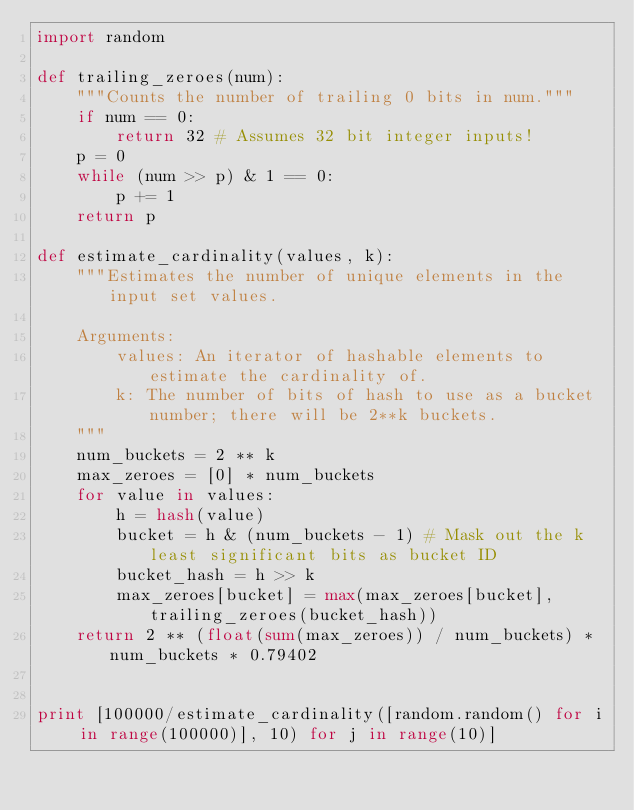<code> <loc_0><loc_0><loc_500><loc_500><_Python_>import random

def trailing_zeroes(num):
    """Counts the number of trailing 0 bits in num."""
    if num == 0:
        return 32 # Assumes 32 bit integer inputs!
    p = 0
    while (num >> p) & 1 == 0:
        p += 1
    return p
 
def estimate_cardinality(values, k):
    """Estimates the number of unique elements in the input set values.
 
    Arguments:
        values: An iterator of hashable elements to estimate the cardinality of.
        k: The number of bits of hash to use as a bucket number; there will be 2**k buckets.
    """
    num_buckets = 2 ** k
    max_zeroes = [0] * num_buckets
    for value in values:
        h = hash(value)
        bucket = h & (num_buckets - 1) # Mask out the k least significant bits as bucket ID
        bucket_hash = h >> k
        max_zeroes[bucket] = max(max_zeroes[bucket], trailing_zeroes(bucket_hash))
    return 2 ** (float(sum(max_zeroes)) / num_buckets) * num_buckets * 0.79402


print [100000/estimate_cardinality([random.random() for i in range(100000)], 10) for j in range(10)]
</code> 